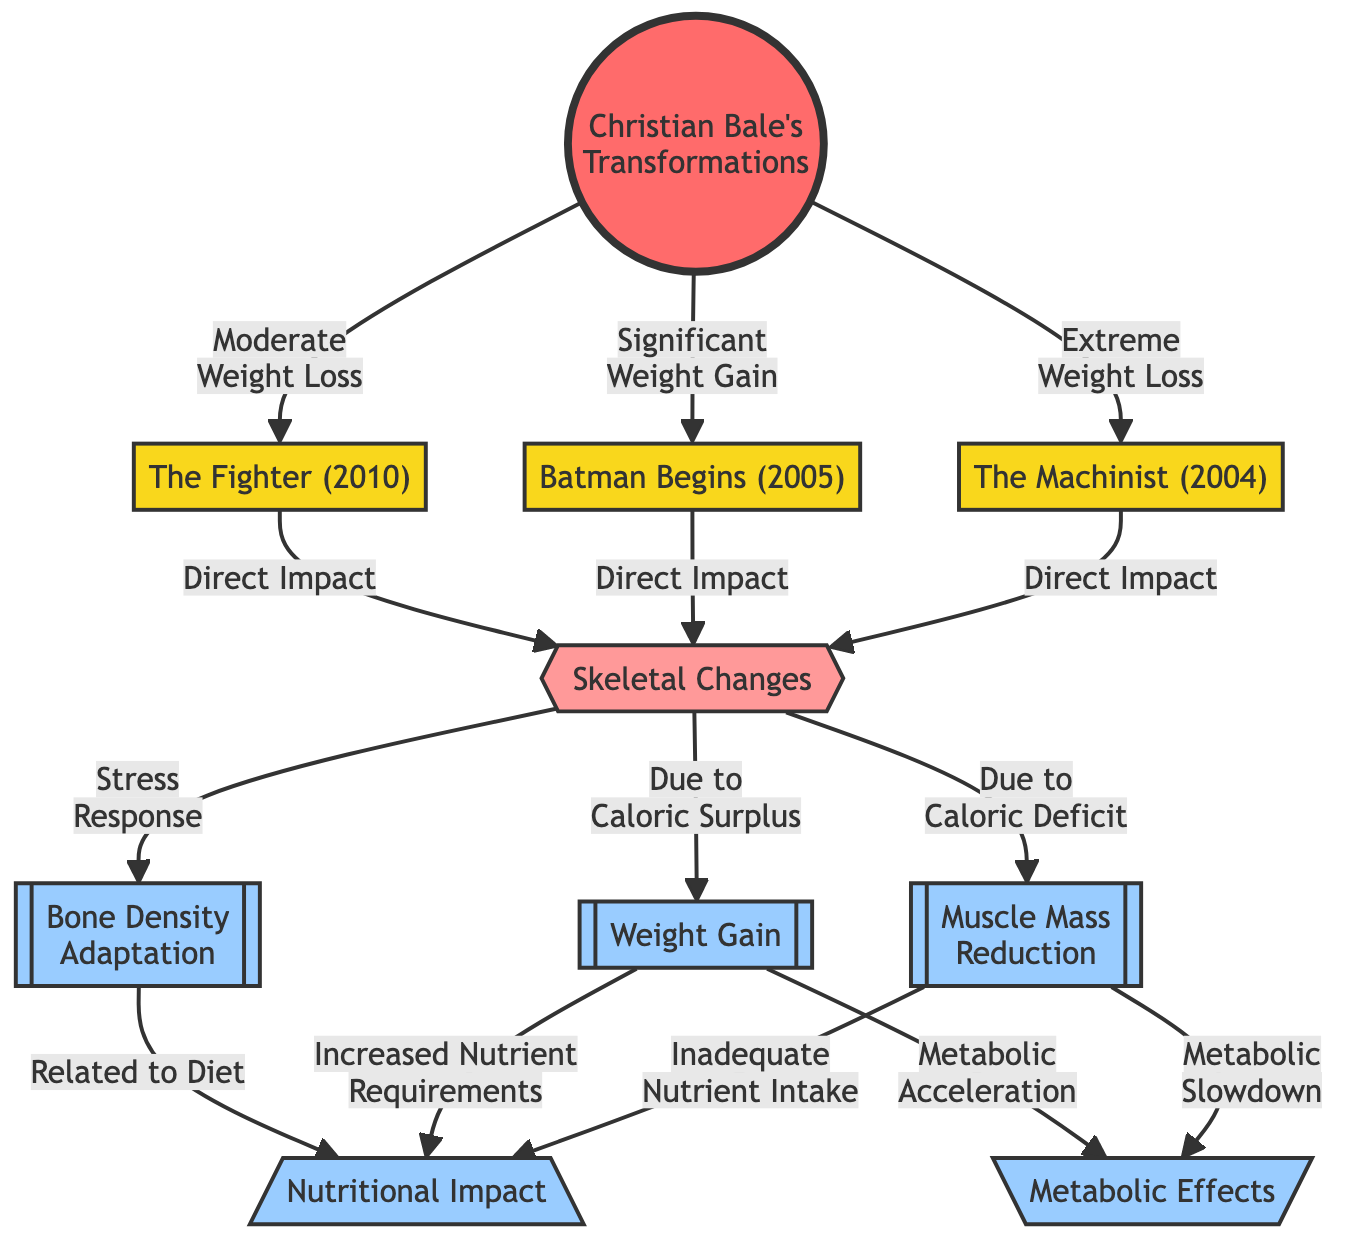What type of transformations does Christian Bale undergo in the diagram? The diagram lists three specific transformations: extreme weight loss, significant weight gain, and moderate weight loss. These are indicated by the arrows leading from the main node "Christian Bale's Transformations."
Answer: extreme weight loss, significant weight gain, moderate weight loss How many films are referenced in relation to Christian Bale's transformations? The diagram includes three specific films: "The Machinist," "Batman Begins," and "The Fighter." Each of these films is connected by arrows to the transformation node, indicating their relevance.
Answer: 3 What is the main node connecting all transformations in the diagram? The central node in the diagram that connects all transformations is titled "Christian Bale's Transformations," indicating it encompasses the different physical transformations Bale undergoes for various roles.
Answer: Christian Bale's Transformations Which transformation leads to muscle mass reduction? The diagram indicates that "Extreme Weight Loss" leads to "Muscle Mass Reduction," demonstrating the direct impact of significant weight loss on muscle tissue.
Answer: Extreme Weight Loss What nutritional impact is related to weight gain? The diagram shows that "Increased Nutrient Requirements" is associated with "Weight Gain," suggesting that gaining weight necessitates a higher intake of nutrients.
Answer: Increased Nutrient Requirements What does the skeletal changes node indicate? The "Skeletal Changes" node serves as a summary of the direct impacts on the skeletal system resulting from the varied transformations, emphasizing that these changes are a consequence of different physical adaptations.
Answer: Skeletal Changes How does metabolic slowdown relate to muscle mass reduction? The diagram depicts a flow where "Muscle Mass Reduction" leads to "Metabolic Slowdown," illustrating that a reduction in muscle can decrease overall metabolic rate.
Answer: Metabolic Slowdown What effect is noted for stress response in context to skeletal adaptation? The diagram indicates that "Bone Density Adaptation" results from stress response, highlighting how physical changes can affect bone density as a reaction to internal and external stress.
Answer: Bone Density Adaptation 